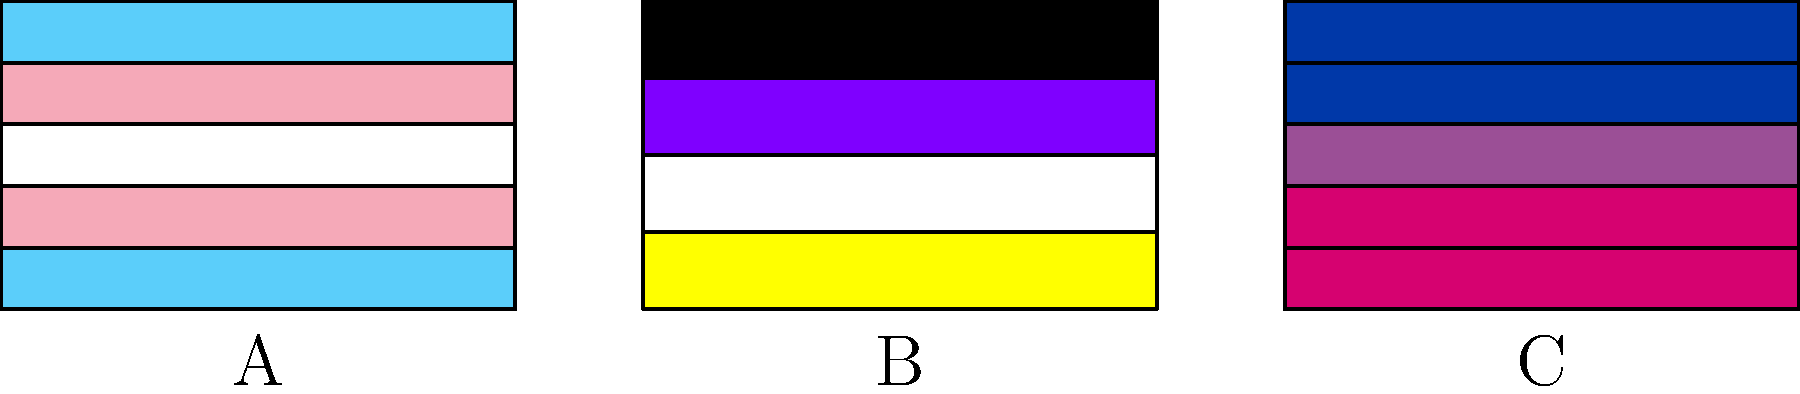Match the LGBTQ+ flags shown above with their corresponding identities:

1. Transgender
2. Non-binary
3. Bisexual

Which letter (A, B, or C) corresponds to each identity? To match the flags with their corresponding identities, let's analyze each flag's design and colors:

1. Transgender flag:
   - Has five horizontal stripes
   - Colors from top to bottom: light blue, light pink, white, light pink, light blue
   - This matches flag A in the image

2. Non-binary flag:
   - Has four horizontal stripes
   - Colors from top to bottom: yellow, white, purple, black
   - This matches flag B in the image

3. Bisexual flag:
   - Has three horizontal stripes, with the middle stripe being narrower
   - Colors from top to bottom: pink (about 2/5 of the flag), purple (middle narrow stripe), blue (about 2/5 of the flag)
   - This matches flag C in the image

Therefore, the correct matching is:
1. Transgender - A
2. Non-binary - B
3. Bisexual - C
Answer: 1-A, 2-B, 3-C 